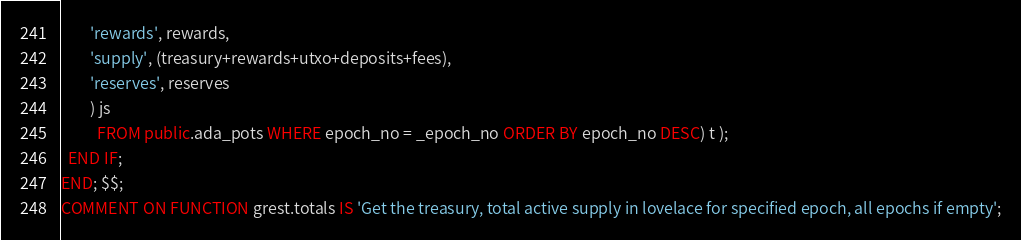<code> <loc_0><loc_0><loc_500><loc_500><_SQL_>        'rewards', rewards,
        'supply', (treasury+rewards+utxo+deposits+fees),
        'reserves', reserves
        ) js
          FROM public.ada_pots WHERE epoch_no = _epoch_no ORDER BY epoch_no DESC) t );
  END IF;
END; $$;
COMMENT ON FUNCTION grest.totals IS 'Get the treasury, total active supply in lovelace for specified epoch, all epochs if empty';
</code> 